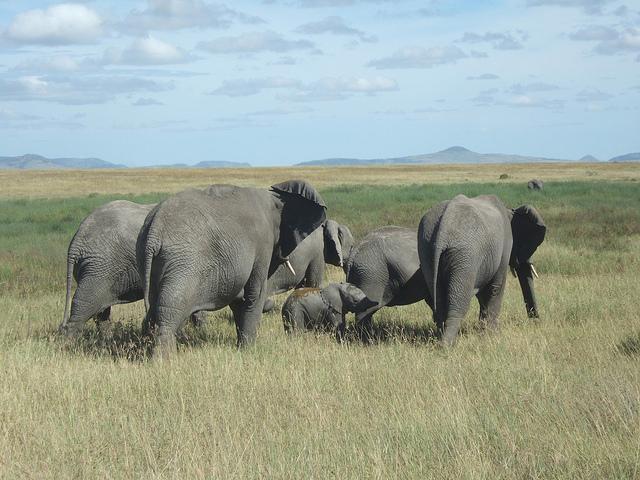How many elephants are there?
Give a very brief answer. 6. How many elephants are in the picture?
Give a very brief answer. 6. How many men are there?
Give a very brief answer. 0. 